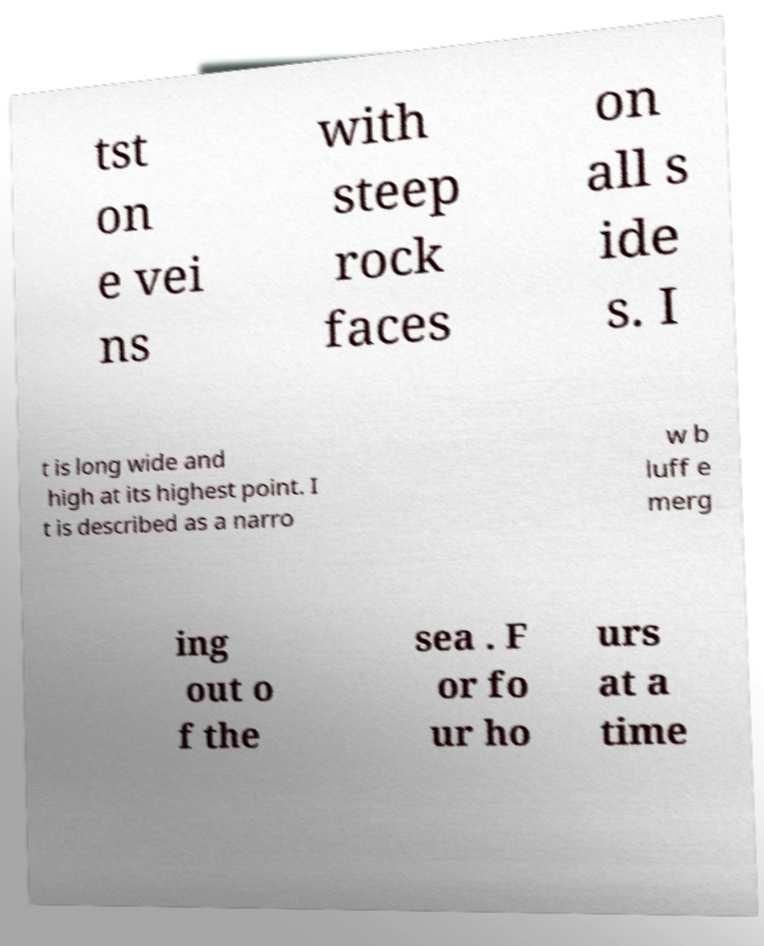What messages or text are displayed in this image? I need them in a readable, typed format. tst on e vei ns with steep rock faces on all s ide s. I t is long wide and high at its highest point. I t is described as a narro w b luff e merg ing out o f the sea . F or fo ur ho urs at a time 